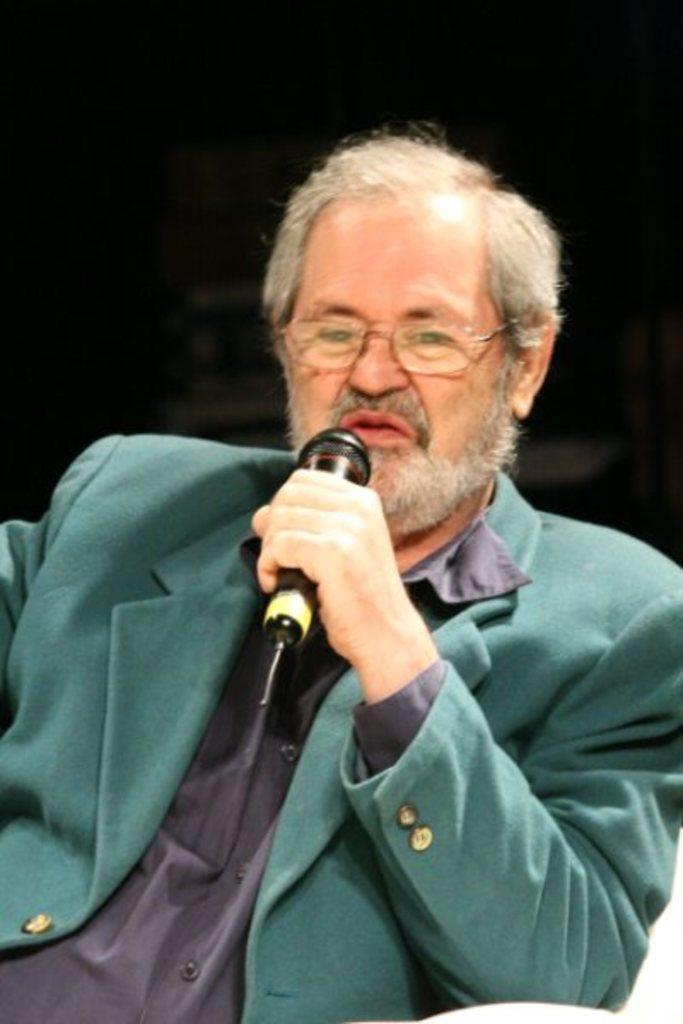Who is the main subject in the image? There is a man in the image. What is the man holding in the image? The man is holding a microphone. What is the man doing in the image? The man is talking. Can you see any visible veins on the man's hand while he is holding the microphone? There is no information about the man's veins in the image, so we cannot determine if they are visible or not. 